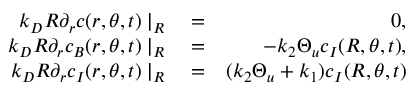Convert formula to latex. <formula><loc_0><loc_0><loc_500><loc_500>\begin{array} { r l r } { k _ { D } R \partial _ { r } c ( r , \theta , t ) | _ { R } } & = } & { 0 , } \\ { k _ { D } R \partial _ { r } c _ { B } ( r , \theta , t ) | _ { R } } & = } & { - k _ { 2 } \Theta _ { u } c _ { I } ( R , \theta , t ) , } \\ { k _ { D } R \partial _ { r } c _ { I } ( r , \theta , t ) | _ { R } } & = } & { ( k _ { 2 } \Theta _ { u } + k _ { 1 } ) c _ { I } ( R , \theta , t ) } \end{array}</formula> 